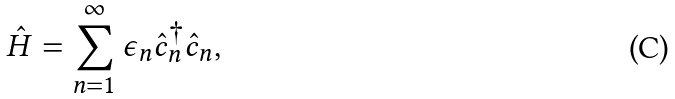Convert formula to latex. <formula><loc_0><loc_0><loc_500><loc_500>\hat { H } = \sum _ { n = 1 } ^ { \infty } \epsilon _ { n } \hat { c } ^ { \dagger } _ { n } \hat { c } _ { n } ,</formula> 